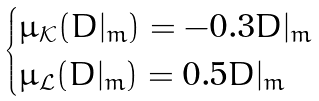<formula> <loc_0><loc_0><loc_500><loc_500>\begin{cases} \mathcal { \mu _ { K } } ( D | _ { m } ) = - 0 . 3 D | _ { m } \\ \mathcal { \mu _ { L } } ( D | _ { m } ) = 0 . 5 D | _ { m } \end{cases}</formula> 